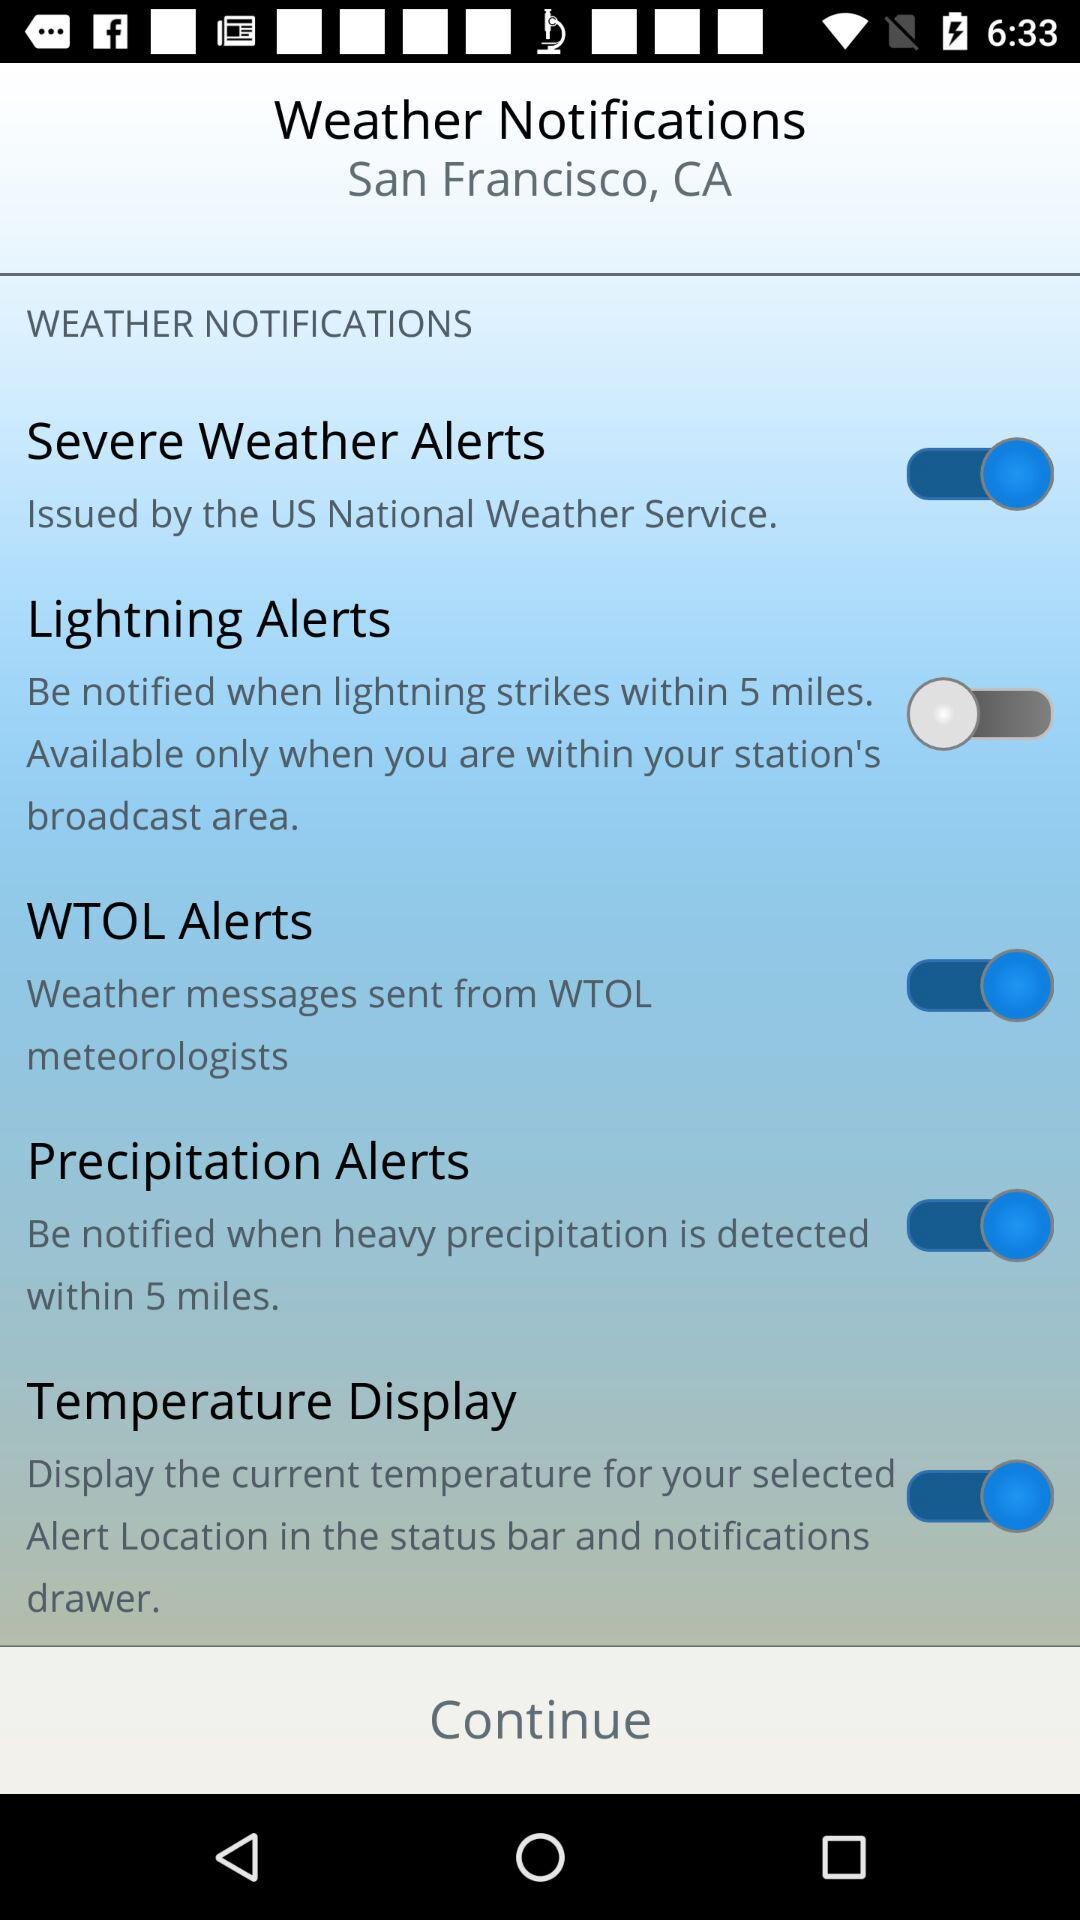What is the mentioned city? The mentioned city is San Francisco. 